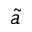Convert formula to latex. <formula><loc_0><loc_0><loc_500><loc_500>\tilde { a }</formula> 